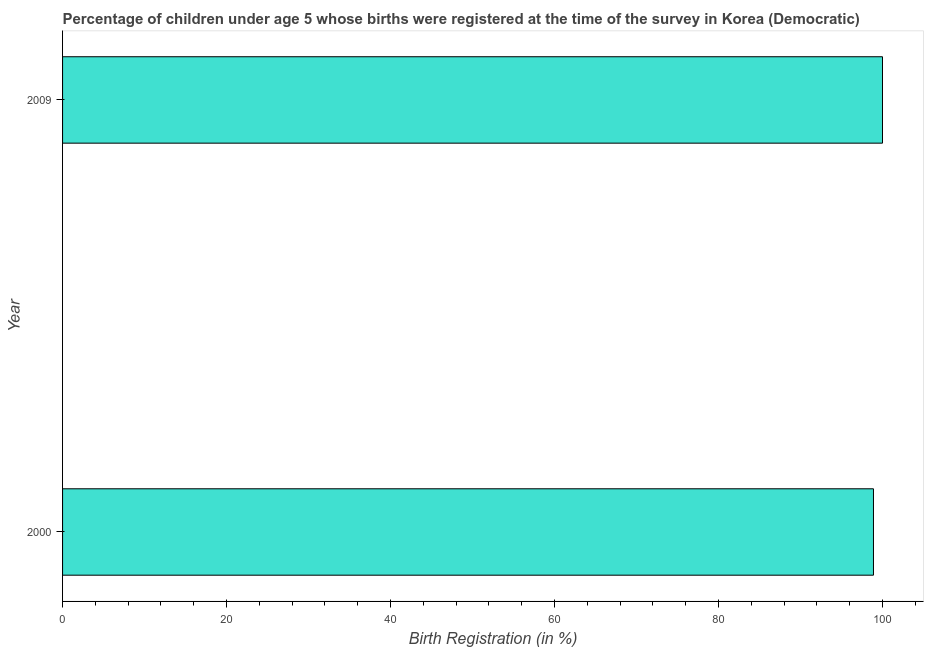Does the graph contain grids?
Provide a short and direct response. No. What is the title of the graph?
Give a very brief answer. Percentage of children under age 5 whose births were registered at the time of the survey in Korea (Democratic). What is the label or title of the X-axis?
Give a very brief answer. Birth Registration (in %). What is the label or title of the Y-axis?
Your answer should be compact. Year. What is the birth registration in 2000?
Provide a short and direct response. 98.9. Across all years, what is the minimum birth registration?
Give a very brief answer. 98.9. In which year was the birth registration minimum?
Keep it short and to the point. 2000. What is the sum of the birth registration?
Offer a terse response. 198.9. What is the difference between the birth registration in 2000 and 2009?
Keep it short and to the point. -1.1. What is the average birth registration per year?
Provide a succinct answer. 99.45. What is the median birth registration?
Give a very brief answer. 99.45. Do a majority of the years between 2000 and 2009 (inclusive) have birth registration greater than 60 %?
Provide a short and direct response. Yes. What is the ratio of the birth registration in 2000 to that in 2009?
Your answer should be compact. 0.99. Is the birth registration in 2000 less than that in 2009?
Make the answer very short. Yes. In how many years, is the birth registration greater than the average birth registration taken over all years?
Make the answer very short. 1. Are all the bars in the graph horizontal?
Your response must be concise. Yes. What is the difference between two consecutive major ticks on the X-axis?
Provide a short and direct response. 20. Are the values on the major ticks of X-axis written in scientific E-notation?
Provide a short and direct response. No. What is the Birth Registration (in %) of 2000?
Ensure brevity in your answer.  98.9. 